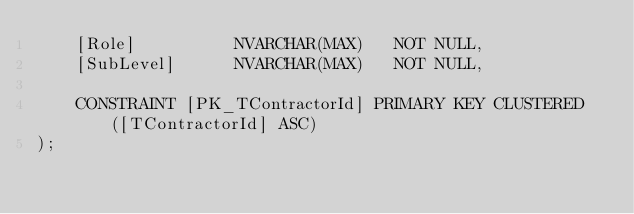<code> <loc_0><loc_0><loc_500><loc_500><_SQL_>	[Role]			NVARCHAR(MAX)	NOT NULL,
	[SubLevel]		NVARCHAR(MAX)	NOT NULL,

	CONSTRAINT [PK_TContractorId] PRIMARY KEY CLUSTERED ([TContractorId] ASC)
);
</code> 